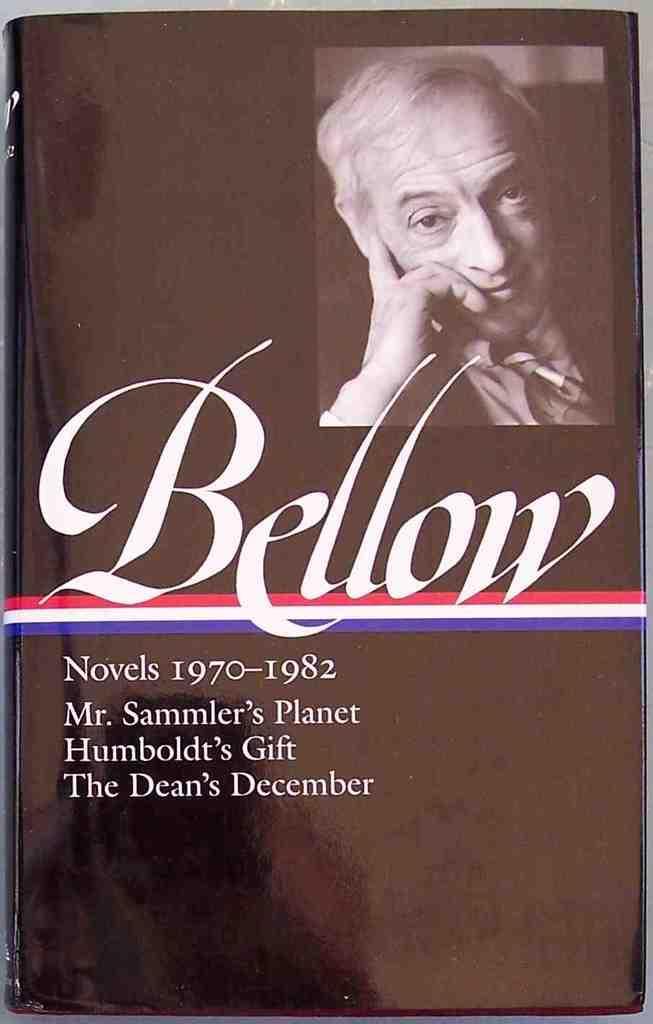Could you give a brief overview of what you see in this image? This is a book. In this book there is an image of a person. Also something is written on the book. 